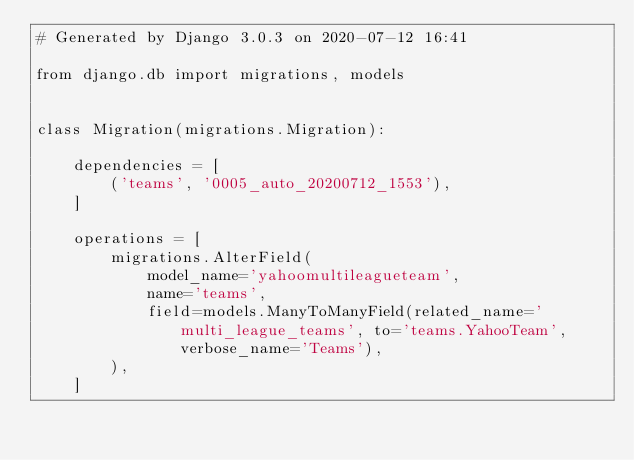<code> <loc_0><loc_0><loc_500><loc_500><_Python_># Generated by Django 3.0.3 on 2020-07-12 16:41

from django.db import migrations, models


class Migration(migrations.Migration):

    dependencies = [
        ('teams', '0005_auto_20200712_1553'),
    ]

    operations = [
        migrations.AlterField(
            model_name='yahoomultileagueteam',
            name='teams',
            field=models.ManyToManyField(related_name='multi_league_teams', to='teams.YahooTeam', verbose_name='Teams'),
        ),
    ]
</code> 